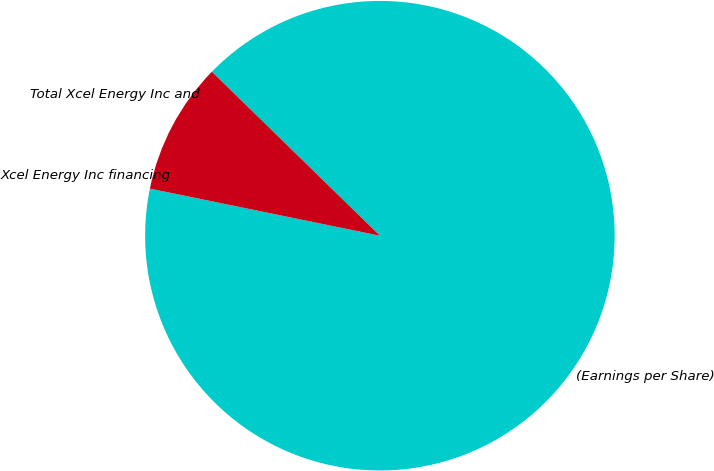Convert chart. <chart><loc_0><loc_0><loc_500><loc_500><pie_chart><fcel>(Earnings per Share)<fcel>Xcel Energy Inc financing<fcel>Total Xcel Energy Inc and<nl><fcel>90.9%<fcel>0.0%<fcel>9.09%<nl></chart> 